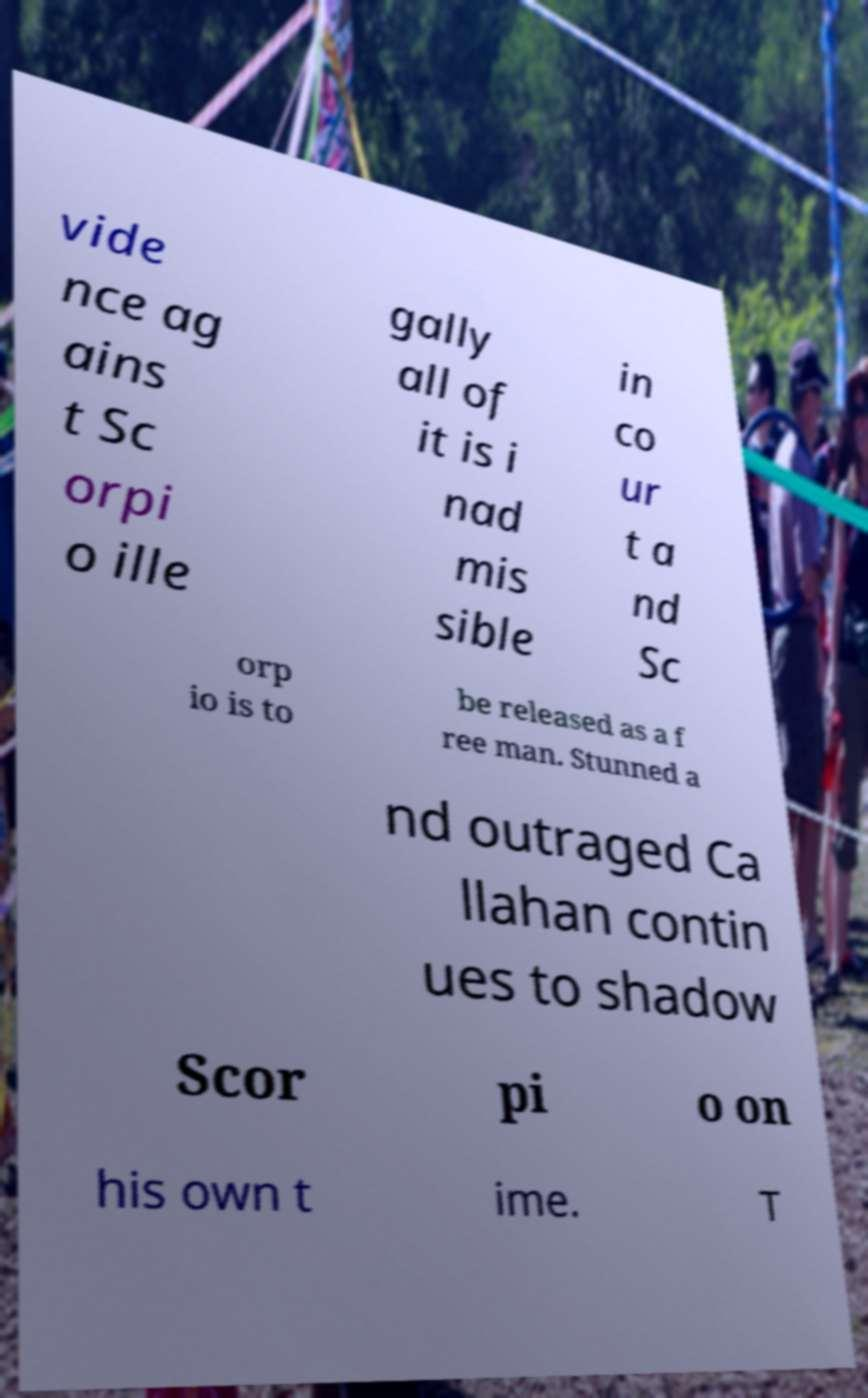Can you accurately transcribe the text from the provided image for me? vide nce ag ains t Sc orpi o ille gally all of it is i nad mis sible in co ur t a nd Sc orp io is to be released as a f ree man. Stunned a nd outraged Ca llahan contin ues to shadow Scor pi o on his own t ime. T 